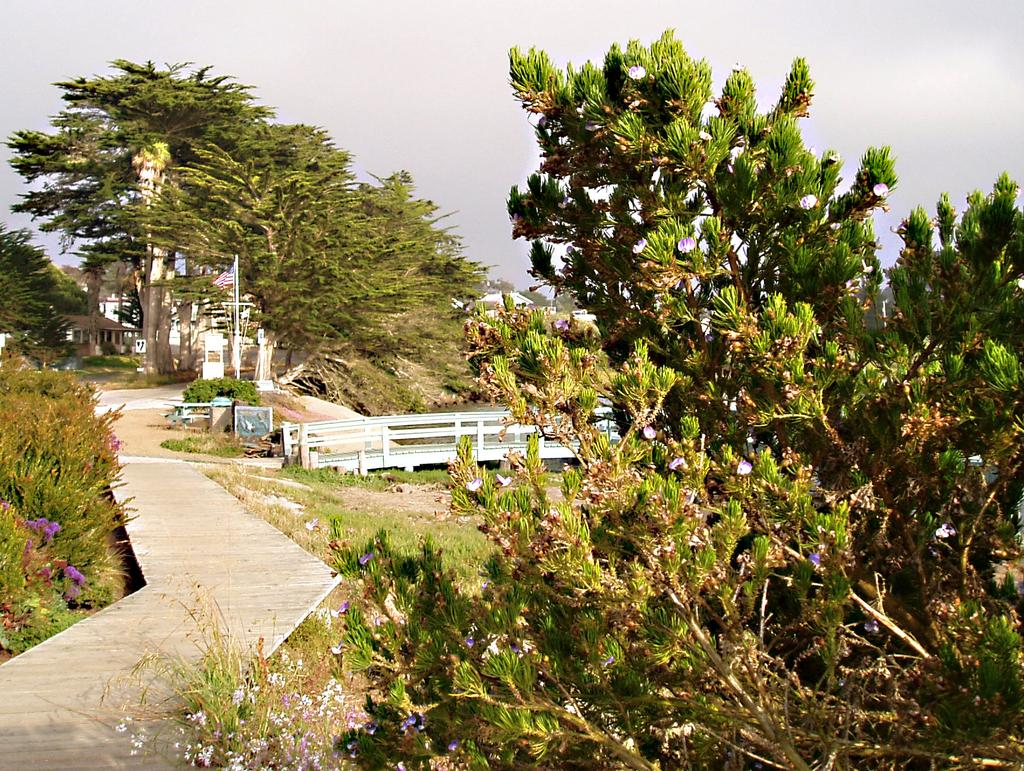What can be seen in the image that people might walk on? There is a path in the image that people might walk on. What type of vegetation is present alongside the path? There are plants on either side of the path. What structure can be seen in the background of the image? There is a bridge in the background of the image. What else is visible in the background of the image? There are trees and the sky visible in the background of the image. What is the average income of the plants on either side of the path? Plants do not have an income, so this question cannot be answered. 